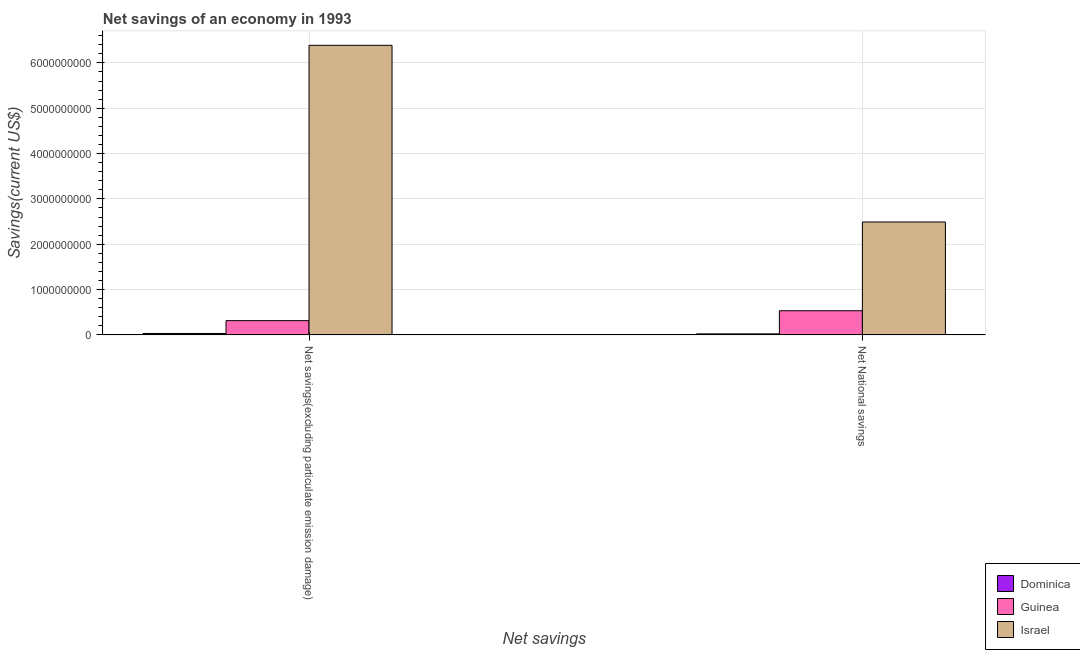How many different coloured bars are there?
Offer a very short reply. 3. How many bars are there on the 2nd tick from the left?
Your response must be concise. 3. What is the label of the 2nd group of bars from the left?
Offer a very short reply. Net National savings. What is the net national savings in Israel?
Offer a terse response. 2.49e+09. Across all countries, what is the maximum net savings(excluding particulate emission damage)?
Provide a succinct answer. 6.39e+09. Across all countries, what is the minimum net national savings?
Your answer should be compact. 2.22e+07. In which country was the net national savings minimum?
Provide a succinct answer. Dominica. What is the total net savings(excluding particulate emission damage) in the graph?
Make the answer very short. 6.73e+09. What is the difference between the net savings(excluding particulate emission damage) in Israel and that in Dominica?
Your answer should be very brief. 6.36e+09. What is the difference between the net savings(excluding particulate emission damage) in Dominica and the net national savings in Israel?
Give a very brief answer. -2.46e+09. What is the average net savings(excluding particulate emission damage) per country?
Provide a short and direct response. 2.24e+09. What is the difference between the net savings(excluding particulate emission damage) and net national savings in Guinea?
Ensure brevity in your answer.  -2.19e+08. In how many countries, is the net savings(excluding particulate emission damage) greater than 1600000000 US$?
Provide a succinct answer. 1. What is the ratio of the net national savings in Guinea to that in Israel?
Provide a succinct answer. 0.21. Is the net national savings in Dominica less than that in Guinea?
Give a very brief answer. Yes. In how many countries, is the net savings(excluding particulate emission damage) greater than the average net savings(excluding particulate emission damage) taken over all countries?
Ensure brevity in your answer.  1. How many countries are there in the graph?
Your response must be concise. 3. Does the graph contain grids?
Your response must be concise. Yes. How many legend labels are there?
Make the answer very short. 3. How are the legend labels stacked?
Ensure brevity in your answer.  Vertical. What is the title of the graph?
Provide a short and direct response. Net savings of an economy in 1993. What is the label or title of the X-axis?
Provide a succinct answer. Net savings. What is the label or title of the Y-axis?
Ensure brevity in your answer.  Savings(current US$). What is the Savings(current US$) of Dominica in Net savings(excluding particulate emission damage)?
Provide a succinct answer. 3.13e+07. What is the Savings(current US$) in Guinea in Net savings(excluding particulate emission damage)?
Your answer should be compact. 3.15e+08. What is the Savings(current US$) in Israel in Net savings(excluding particulate emission damage)?
Provide a succinct answer. 6.39e+09. What is the Savings(current US$) in Dominica in Net National savings?
Your answer should be compact. 2.22e+07. What is the Savings(current US$) in Guinea in Net National savings?
Offer a very short reply. 5.33e+08. What is the Savings(current US$) in Israel in Net National savings?
Make the answer very short. 2.49e+09. Across all Net savings, what is the maximum Savings(current US$) in Dominica?
Provide a short and direct response. 3.13e+07. Across all Net savings, what is the maximum Savings(current US$) in Guinea?
Offer a very short reply. 5.33e+08. Across all Net savings, what is the maximum Savings(current US$) in Israel?
Offer a terse response. 6.39e+09. Across all Net savings, what is the minimum Savings(current US$) in Dominica?
Your answer should be compact. 2.22e+07. Across all Net savings, what is the minimum Savings(current US$) in Guinea?
Your answer should be compact. 3.15e+08. Across all Net savings, what is the minimum Savings(current US$) of Israel?
Your answer should be compact. 2.49e+09. What is the total Savings(current US$) of Dominica in the graph?
Your answer should be very brief. 5.35e+07. What is the total Savings(current US$) in Guinea in the graph?
Your answer should be very brief. 8.48e+08. What is the total Savings(current US$) of Israel in the graph?
Keep it short and to the point. 8.88e+09. What is the difference between the Savings(current US$) in Dominica in Net savings(excluding particulate emission damage) and that in Net National savings?
Ensure brevity in your answer.  9.07e+06. What is the difference between the Savings(current US$) of Guinea in Net savings(excluding particulate emission damage) and that in Net National savings?
Provide a short and direct response. -2.19e+08. What is the difference between the Savings(current US$) of Israel in Net savings(excluding particulate emission damage) and that in Net National savings?
Provide a short and direct response. 3.90e+09. What is the difference between the Savings(current US$) in Dominica in Net savings(excluding particulate emission damage) and the Savings(current US$) in Guinea in Net National savings?
Keep it short and to the point. -5.02e+08. What is the difference between the Savings(current US$) of Dominica in Net savings(excluding particulate emission damage) and the Savings(current US$) of Israel in Net National savings?
Give a very brief answer. -2.46e+09. What is the difference between the Savings(current US$) in Guinea in Net savings(excluding particulate emission damage) and the Savings(current US$) in Israel in Net National savings?
Your answer should be very brief. -2.18e+09. What is the average Savings(current US$) in Dominica per Net savings?
Provide a short and direct response. 2.68e+07. What is the average Savings(current US$) in Guinea per Net savings?
Keep it short and to the point. 4.24e+08. What is the average Savings(current US$) in Israel per Net savings?
Your response must be concise. 4.44e+09. What is the difference between the Savings(current US$) in Dominica and Savings(current US$) in Guinea in Net savings(excluding particulate emission damage)?
Your response must be concise. -2.83e+08. What is the difference between the Savings(current US$) of Dominica and Savings(current US$) of Israel in Net savings(excluding particulate emission damage)?
Your answer should be very brief. -6.36e+09. What is the difference between the Savings(current US$) in Guinea and Savings(current US$) in Israel in Net savings(excluding particulate emission damage)?
Provide a short and direct response. -6.07e+09. What is the difference between the Savings(current US$) in Dominica and Savings(current US$) in Guinea in Net National savings?
Provide a short and direct response. -5.11e+08. What is the difference between the Savings(current US$) in Dominica and Savings(current US$) in Israel in Net National savings?
Give a very brief answer. -2.47e+09. What is the difference between the Savings(current US$) of Guinea and Savings(current US$) of Israel in Net National savings?
Make the answer very short. -1.96e+09. What is the ratio of the Savings(current US$) in Dominica in Net savings(excluding particulate emission damage) to that in Net National savings?
Ensure brevity in your answer.  1.41. What is the ratio of the Savings(current US$) of Guinea in Net savings(excluding particulate emission damage) to that in Net National savings?
Your answer should be very brief. 0.59. What is the ratio of the Savings(current US$) in Israel in Net savings(excluding particulate emission damage) to that in Net National savings?
Offer a terse response. 2.57. What is the difference between the highest and the second highest Savings(current US$) in Dominica?
Ensure brevity in your answer.  9.07e+06. What is the difference between the highest and the second highest Savings(current US$) in Guinea?
Make the answer very short. 2.19e+08. What is the difference between the highest and the second highest Savings(current US$) in Israel?
Your answer should be very brief. 3.90e+09. What is the difference between the highest and the lowest Savings(current US$) in Dominica?
Provide a succinct answer. 9.07e+06. What is the difference between the highest and the lowest Savings(current US$) of Guinea?
Ensure brevity in your answer.  2.19e+08. What is the difference between the highest and the lowest Savings(current US$) in Israel?
Provide a short and direct response. 3.90e+09. 